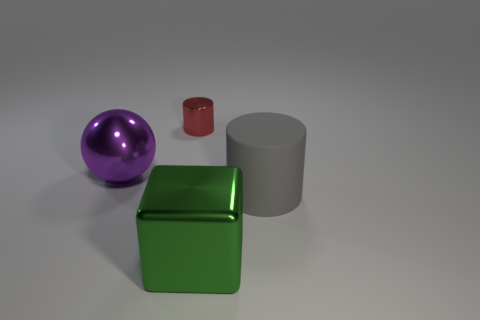There is a shiny thing that is in front of the sphere; is it the same shape as the large metal object that is behind the block?
Your answer should be compact. No. Are there any gray rubber objects in front of the matte cylinder?
Offer a terse response. No. The large object that is the same shape as the tiny red object is what color?
Give a very brief answer. Gray. Is there any other thing that has the same shape as the big green metal thing?
Keep it short and to the point. No. What is the material of the cylinder in front of the large purple object?
Offer a very short reply. Rubber. What is the size of the red metal object that is the same shape as the rubber thing?
Your response must be concise. Small. How many purple balls have the same material as the red cylinder?
Provide a succinct answer. 1. What number of large balls are the same color as the small thing?
Your response must be concise. 0. What number of things are either things on the right side of the small cylinder or large shiny things that are behind the green object?
Provide a succinct answer. 3. Are there fewer large green metal things that are behind the big green metallic block than tiny red cylinders?
Your answer should be very brief. Yes. 